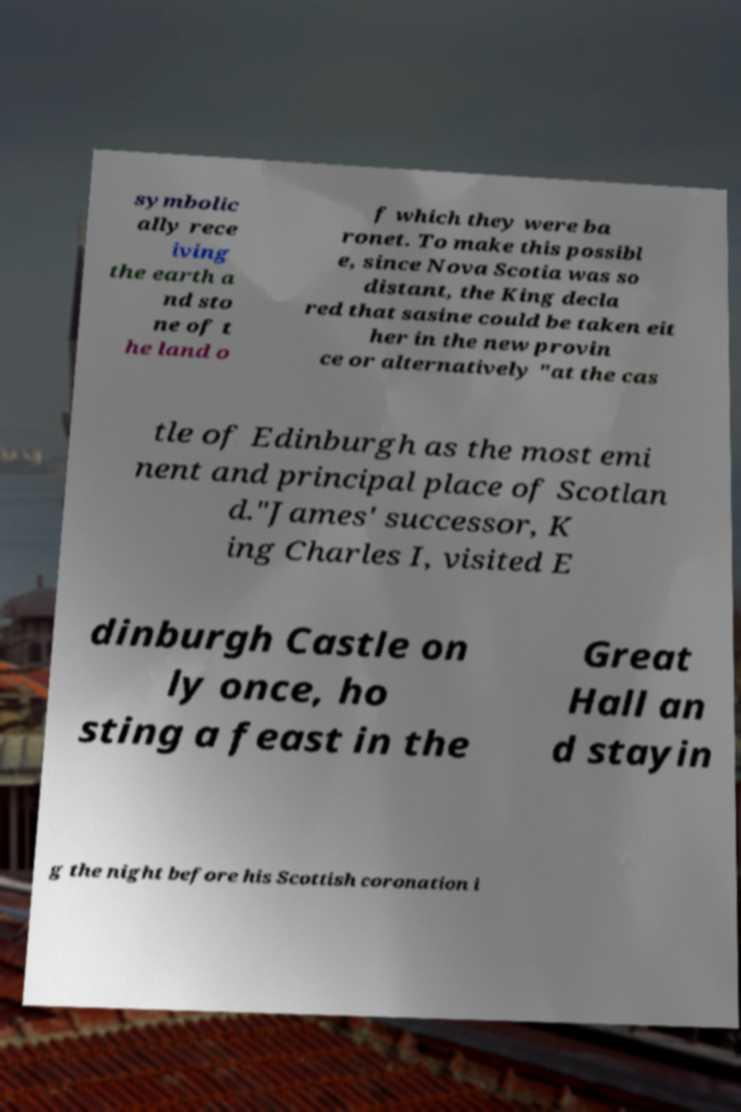Please read and relay the text visible in this image. What does it say? symbolic ally rece iving the earth a nd sto ne of t he land o f which they were ba ronet. To make this possibl e, since Nova Scotia was so distant, the King decla red that sasine could be taken eit her in the new provin ce or alternatively "at the cas tle of Edinburgh as the most emi nent and principal place of Scotlan d."James' successor, K ing Charles I, visited E dinburgh Castle on ly once, ho sting a feast in the Great Hall an d stayin g the night before his Scottish coronation i 